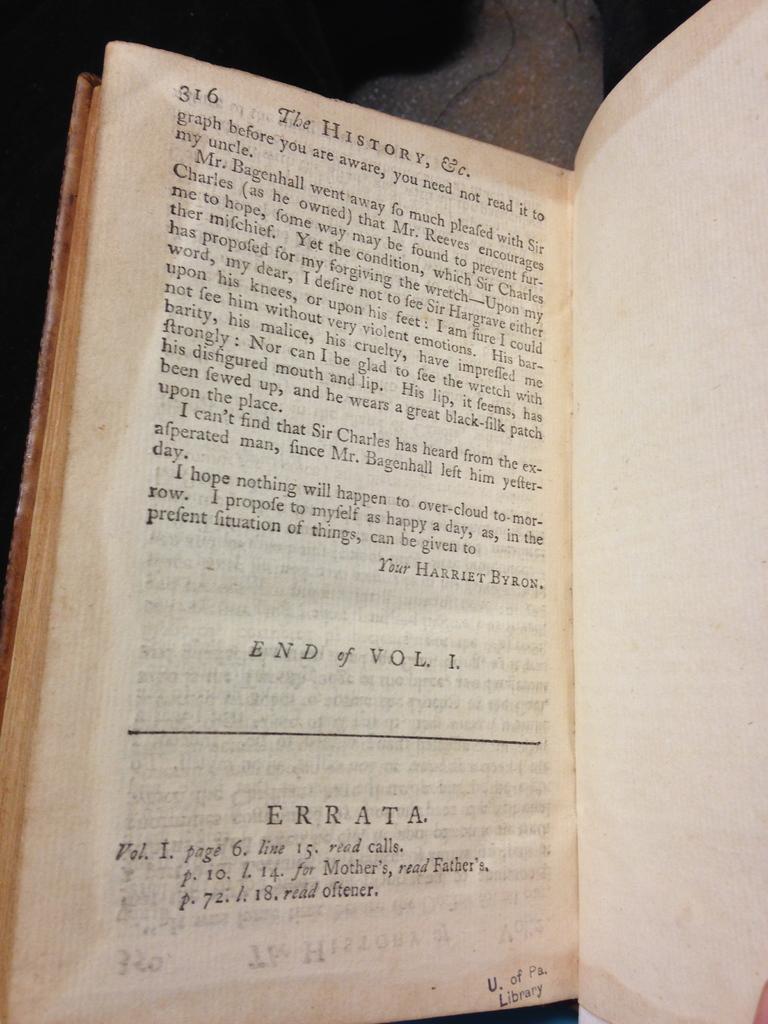Is this the end of volume 1?
Your answer should be very brief. Yes. 